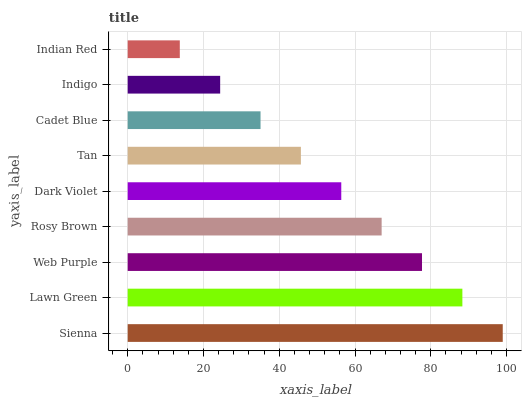Is Indian Red the minimum?
Answer yes or no. Yes. Is Sienna the maximum?
Answer yes or no. Yes. Is Lawn Green the minimum?
Answer yes or no. No. Is Lawn Green the maximum?
Answer yes or no. No. Is Sienna greater than Lawn Green?
Answer yes or no. Yes. Is Lawn Green less than Sienna?
Answer yes or no. Yes. Is Lawn Green greater than Sienna?
Answer yes or no. No. Is Sienna less than Lawn Green?
Answer yes or no. No. Is Dark Violet the high median?
Answer yes or no. Yes. Is Dark Violet the low median?
Answer yes or no. Yes. Is Sienna the high median?
Answer yes or no. No. Is Cadet Blue the low median?
Answer yes or no. No. 